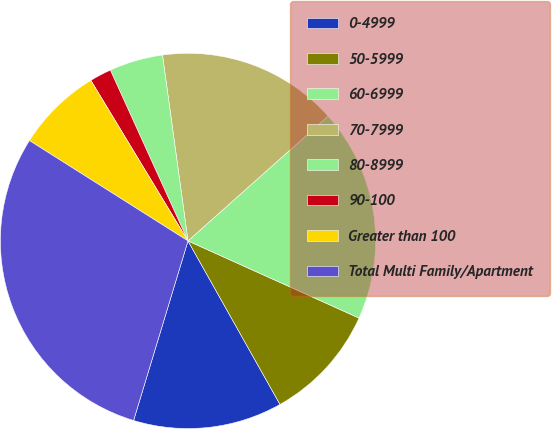Convert chart to OTSL. <chart><loc_0><loc_0><loc_500><loc_500><pie_chart><fcel>0-4999<fcel>50-5999<fcel>60-6999<fcel>70-7999<fcel>80-8999<fcel>90-100<fcel>Greater than 100<fcel>Total Multi Family/Apartment<nl><fcel>12.84%<fcel>10.1%<fcel>18.33%<fcel>15.59%<fcel>4.62%<fcel>1.87%<fcel>7.36%<fcel>29.3%<nl></chart> 